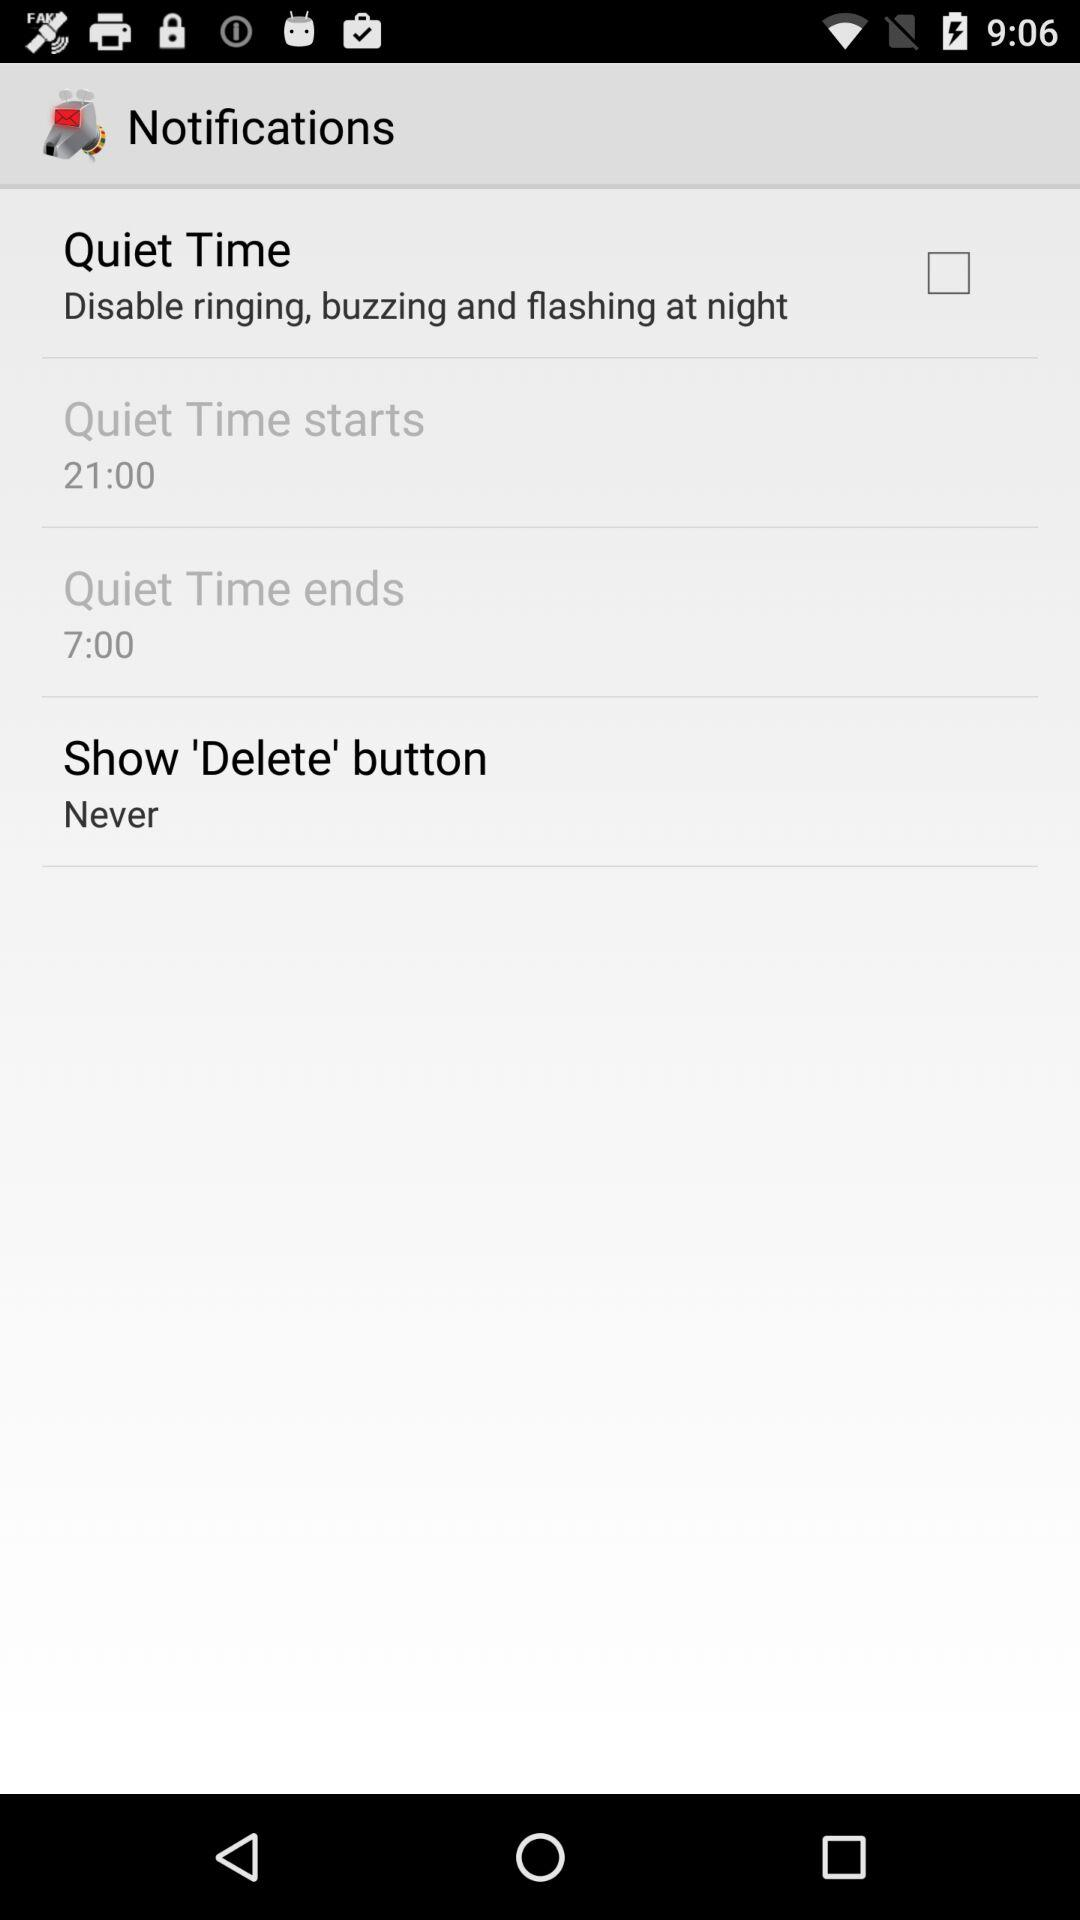What are the actions of quiet time? The actions of quiet time are "Disable ringing", "buzzing" and "flashing at night". 